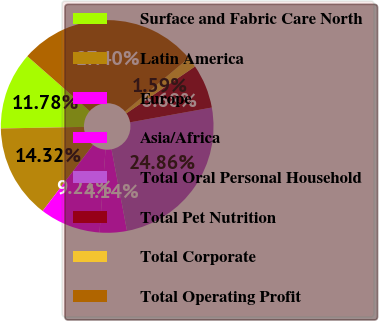<chart> <loc_0><loc_0><loc_500><loc_500><pie_chart><fcel>Surface and Fabric Care North<fcel>Latin America<fcel>Europe<fcel>Asia/Africa<fcel>Total Oral Personal Household<fcel>Total Pet Nutrition<fcel>Total Corporate<fcel>Total Operating Profit<nl><fcel>11.78%<fcel>14.32%<fcel>9.23%<fcel>4.14%<fcel>24.86%<fcel>6.68%<fcel>1.59%<fcel>27.4%<nl></chart> 